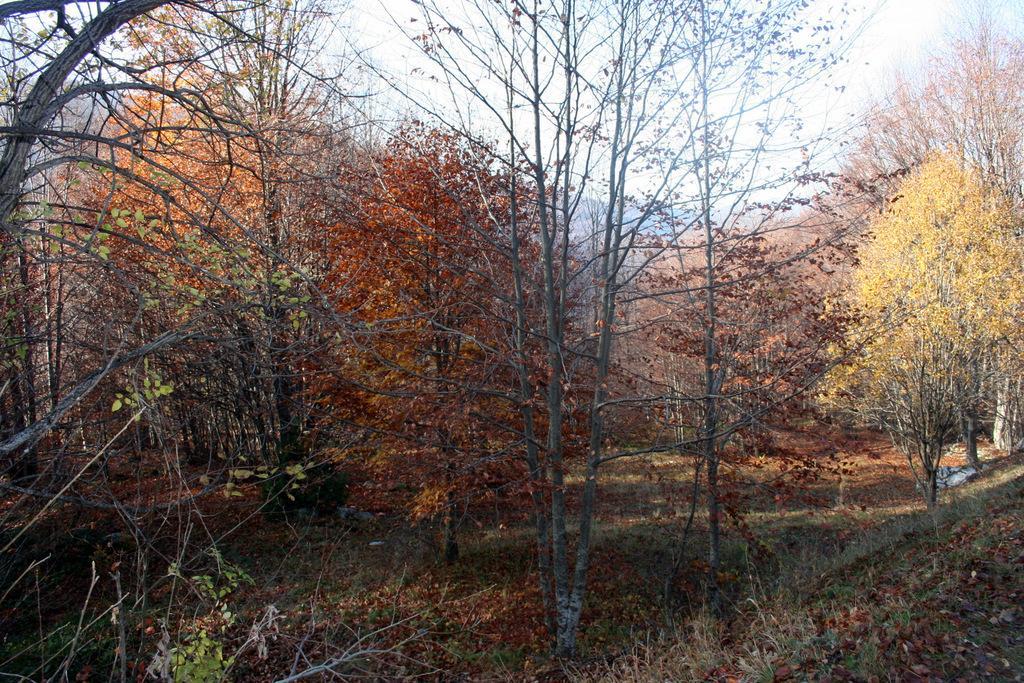Could you give a brief overview of what you see in this image? In this picture I can see so many trees, grass and dry leaves on the ground. 